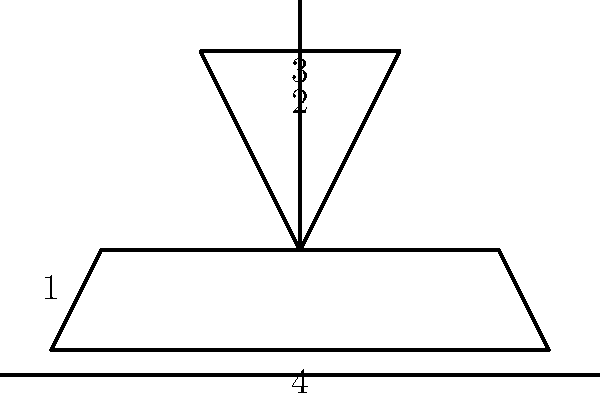Arrange the parts of this Viking ship in the correct order from bottom to top: To arrange the Viking ship parts correctly from bottom to top, let's analyze each numbered component:

1. Part 1 represents the hull of the ship. This is the main body of the vessel and forms the base upon which all other parts are built.

2. Part 4 shows an oar. Oars are positioned along the sides of the hull, extending outwards.

3. Part 3 is the mast. The mast is a vertical pole that rises from the center of the hull and supports the sail.

4. Part 2 depicts the sail. The sail is attached to the top of the mast and catches the wind to propel the ship.

Following the logical construction of a ship, we start with the hull as the foundation, then add the oars for rowing, followed by the mast for stability, and finally the sail at the top for wind propulsion.

Therefore, the correct order from bottom to top is: 1, 4, 3, 2.
Answer: 1, 4, 3, 2 